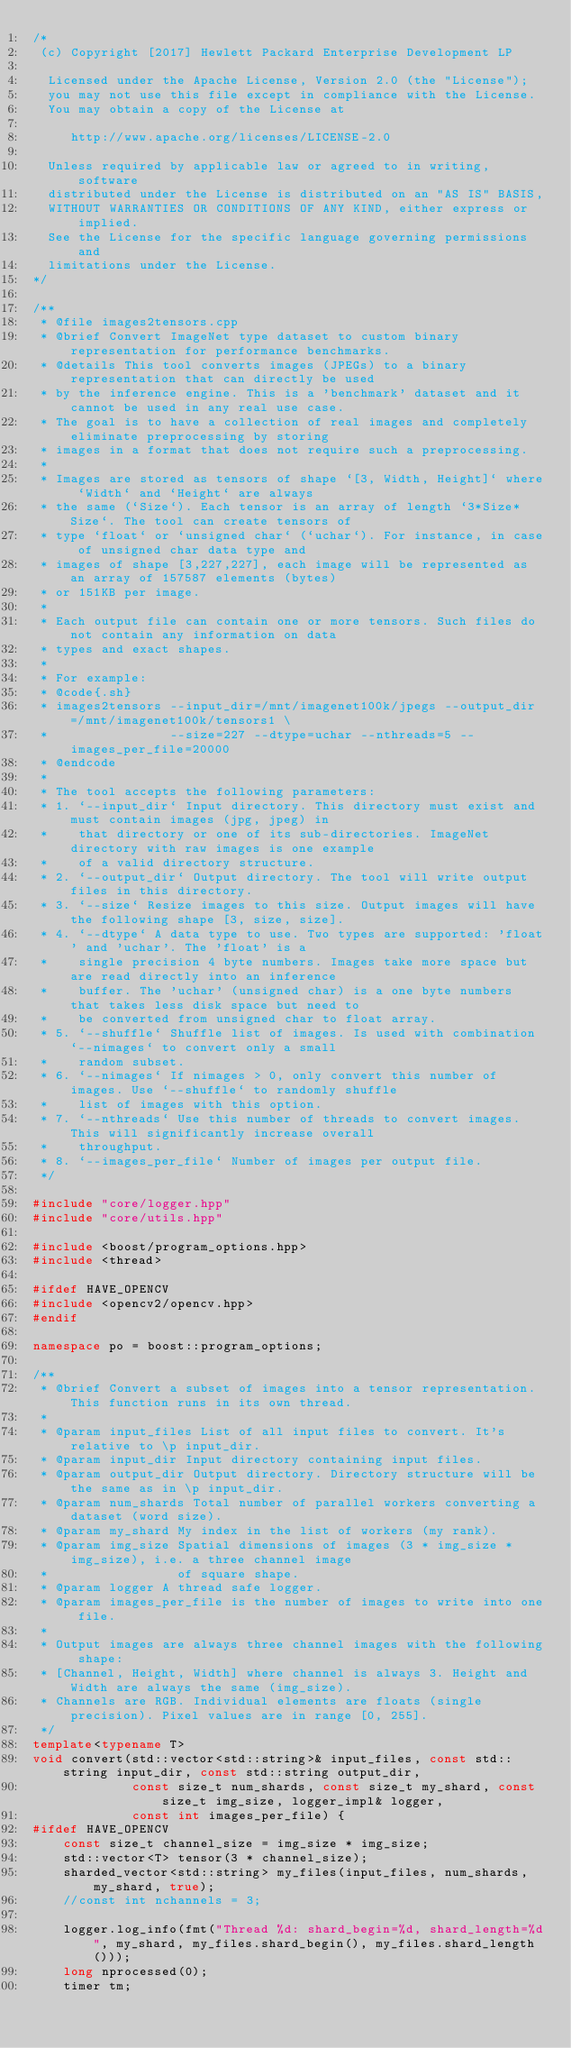Convert code to text. <code><loc_0><loc_0><loc_500><loc_500><_C++_>/*
 (c) Copyright [2017] Hewlett Packard Enterprise Development LP
 
  Licensed under the Apache License, Version 2.0 (the "License");
  you may not use this file except in compliance with the License.
  You may obtain a copy of the License at
 
     http://www.apache.org/licenses/LICENSE-2.0
 
  Unless required by applicable law or agreed to in writing, software
  distributed under the License is distributed on an "AS IS" BASIS,
  WITHOUT WARRANTIES OR CONDITIONS OF ANY KIND, either express or implied.
  See the License for the specific language governing permissions and
  limitations under the License.
*/

/**
 * @file images2tensors.cpp
 * @brief Convert ImageNet type dataset to custom binary representation for performance benchmarks.
 * @details This tool converts images (JPEGs) to a binary representation that can directly be used
 * by the inference engine. This is a 'benchmark' dataset and it cannot be used in any real use case.
 * The goal is to have a collection of real images and completely eliminate preprocessing by storing
 * images in a format that does not require such a preprocessing.
 * 
 * Images are stored as tensors of shape `[3, Width, Height]` where `Width` and `Height` are always
 * the same (`Size`). Each tensor is an array of length `3*Size*Size`. The tool can create tensors of
 * type `float` or `unsigned char` (`uchar`). For instance, in case of unsigned char data type and 
 * images of shape [3,227,227], each image will be represented as an array of 157587 elements (bytes)
 * or 151KB per image.
 * 
 * Each output file can contain one or more tensors. Such files do not contain any information on data
 * types and exact shapes.
 * 
 * For example:
 * @code{.sh}
 * images2tensors --input_dir=/mnt/imagenet100k/jpegs --output_dir=/mnt/imagenet100k/tensors1 \
 *                --size=227 --dtype=uchar --nthreads=5 --images_per_file=20000
 * @endcode
 * 
 * The tool accepts the following parameters:
 * 1. `--input_dir` Input directory. This directory must exist and must contain images (jpg, jpeg) in 
 *    that directory or one of its sub-directories. ImageNet directory with raw images is one example
 *    of a valid directory structure.
 * 2. `--output_dir` Output directory. The tool will write output files in this directory.
 * 3. `--size` Resize images to this size. Output images will have the following shape [3, size, size].
 * 4. `--dtype` A data type to use. Two types are supported: 'float' and 'uchar'. The 'float' is a
 *    single precision 4 byte numbers. Images take more space but are read directly into an inference
 *    buffer. The 'uchar' (unsigned char) is a one byte numbers that takes less disk space but need to
 *    be converted from unsigned char to float array.
 * 5. `--shuffle` Shuffle list of images. Is used with combination `--nimages` to convert only a small
 *    random subset.
 * 6. `--nimages` If nimages > 0, only convert this number of images. Use `--shuffle` to randomly shuffle
 *    list of images with this option.
 * 7. `--nthreads` Use this number of threads to convert images. This will significantly increase overall
 *    throughput.
 * 8. `--images_per_file` Number of images per output file.
 */

#include "core/logger.hpp"
#include "core/utils.hpp"

#include <boost/program_options.hpp>
#include <thread>

#ifdef HAVE_OPENCV
#include <opencv2/opencv.hpp>
#endif

namespace po = boost::program_options;

/**
 * @brief Convert a subset of images into a tensor representation. This function runs in its own thread.
 * 
 * @param input_files List of all input files to convert. It's relative to \p input_dir.
 * @param input_dir Input directory containing input files.
 * @param output_dir Output directory. Directory structure will be the same as in \p input_dir.
 * @param num_shards Total number of parallel workers converting a dataset (word size).
 * @param my_shard My index in the list of workers (my rank).
 * @param img_size Spatial dimensions of images (3 * img_size * img_size), i.e. a three channel image
 *                 of square shape.
 * @param logger A thread safe logger.
 * @param images_per_file is the number of images to write into one file.
 * 
 * Output images are always three channel images with the following shape:
 * [Channel, Height, Width] where channel is always 3. Height and Width are always the same (img_size).
 * Channels are RGB. Individual elements are floats (single precision). Pixel values are in range [0, 255].
 */
template<typename T>
void convert(std::vector<std::string>& input_files, const std::string input_dir, const std::string output_dir,
             const size_t num_shards, const size_t my_shard, const size_t img_size, logger_impl& logger,
             const int images_per_file) {
#ifdef HAVE_OPENCV
    const size_t channel_size = img_size * img_size;
    std::vector<T> tensor(3 * channel_size);
    sharded_vector<std::string> my_files(input_files, num_shards, my_shard, true);
    //const int nchannels = 3;
    
    logger.log_info(fmt("Thread %d: shard_begin=%d, shard_length=%d", my_shard, my_files.shard_begin(), my_files.shard_length()));
    long nprocessed(0);
    timer tm;</code> 